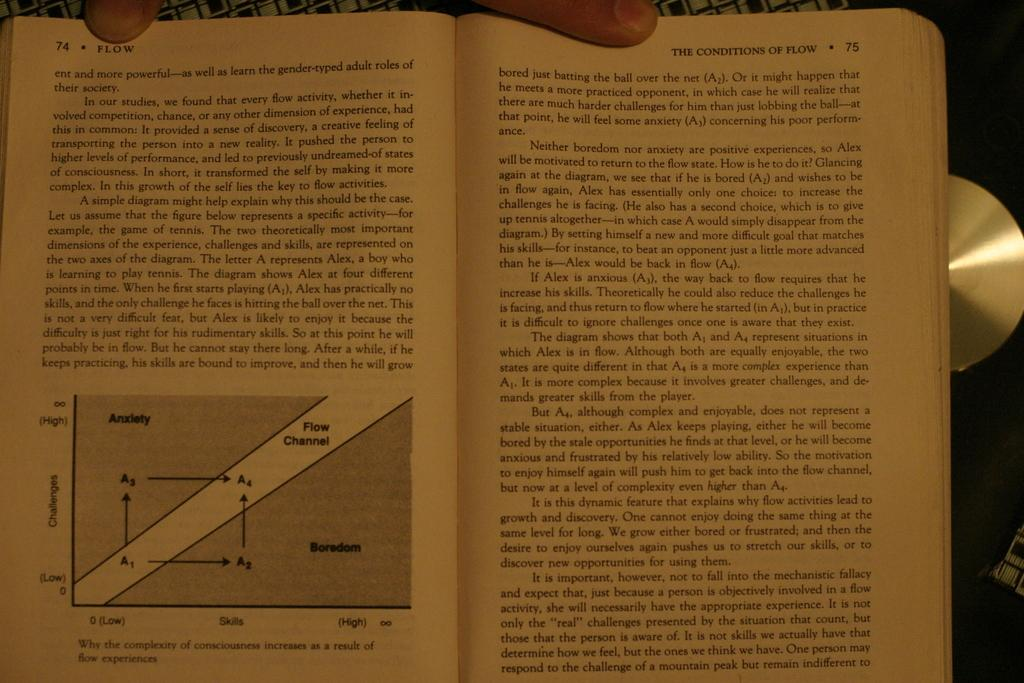<image>
Present a compact description of the photo's key features. A person has his fingers on a book that is opened to pages 74 and 75. 